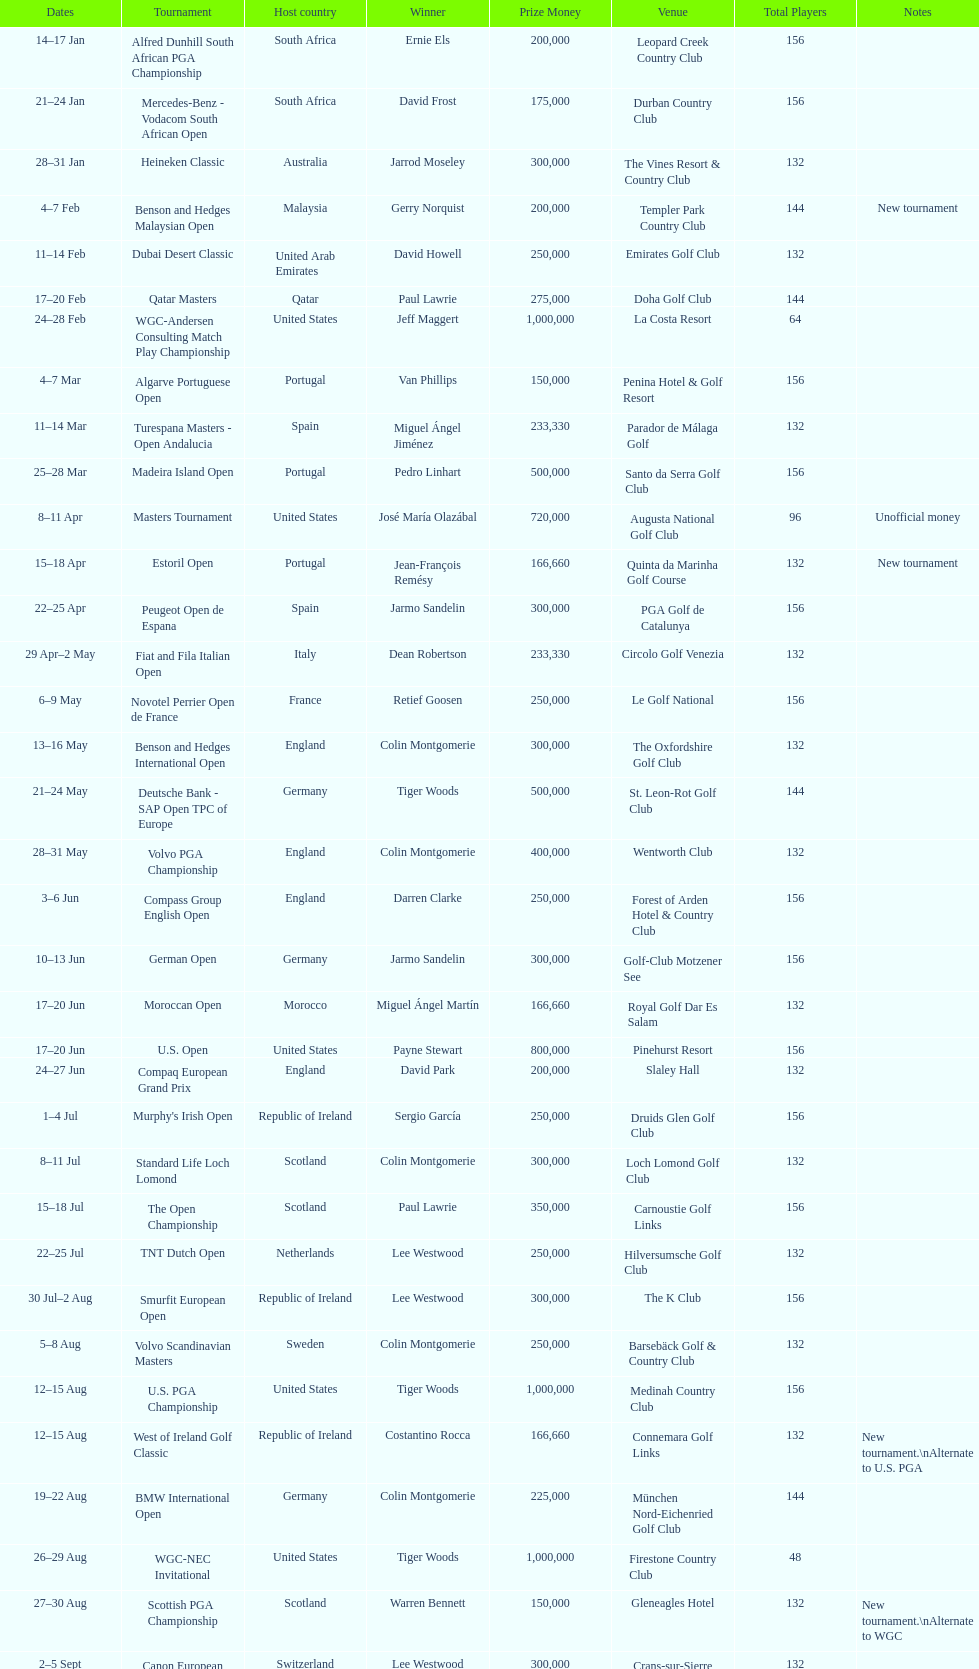Other than qatar masters, name a tournament that was in february. Dubai Desert Classic. 